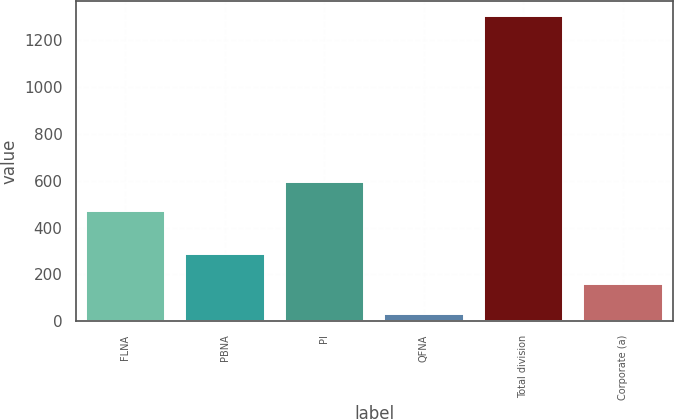Convert chart. <chart><loc_0><loc_0><loc_500><loc_500><bar_chart><fcel>FLNA<fcel>PBNA<fcel>PI<fcel>QFNA<fcel>Total division<fcel>Corporate (a)<nl><fcel>469<fcel>287.2<fcel>596.1<fcel>33<fcel>1304<fcel>160.1<nl></chart> 